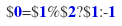Convert code to text. <code><loc_0><loc_0><loc_500><loc_500><_Awk_>$0=$1%$2?$1:-1</code> 